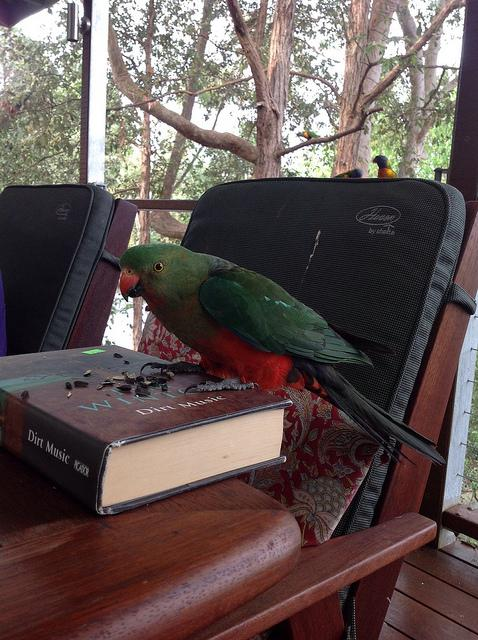What makes up the bulk of this bird's diet?

Choices:
A) vegetables
B) insects
C) seeds
D) fruits fruits 